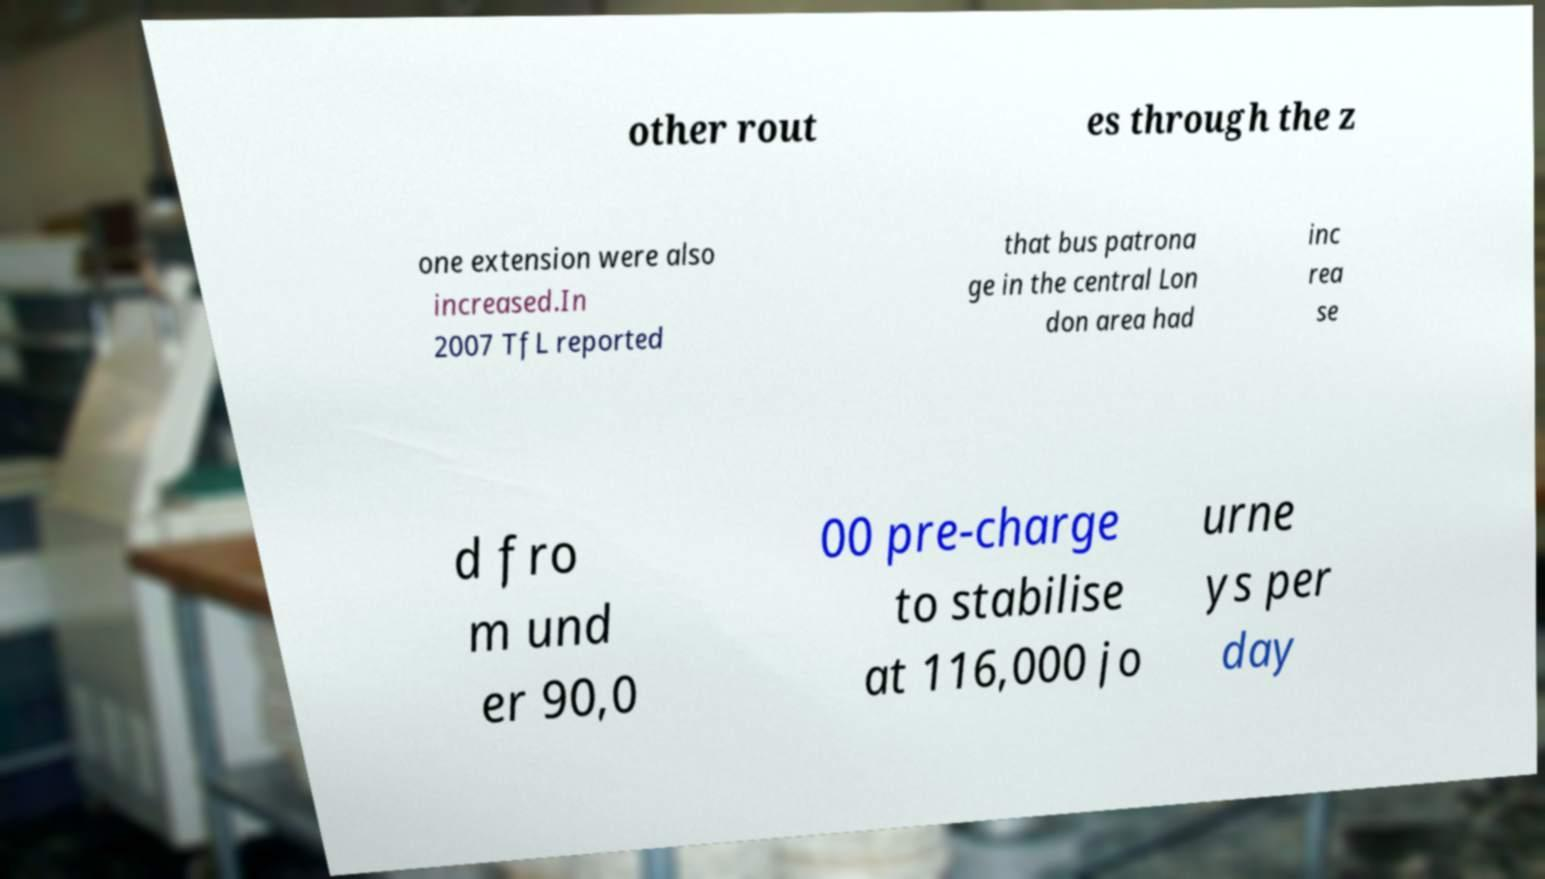Please identify and transcribe the text found in this image. other rout es through the z one extension were also increased.In 2007 TfL reported that bus patrona ge in the central Lon don area had inc rea se d fro m und er 90,0 00 pre-charge to stabilise at 116,000 jo urne ys per day 